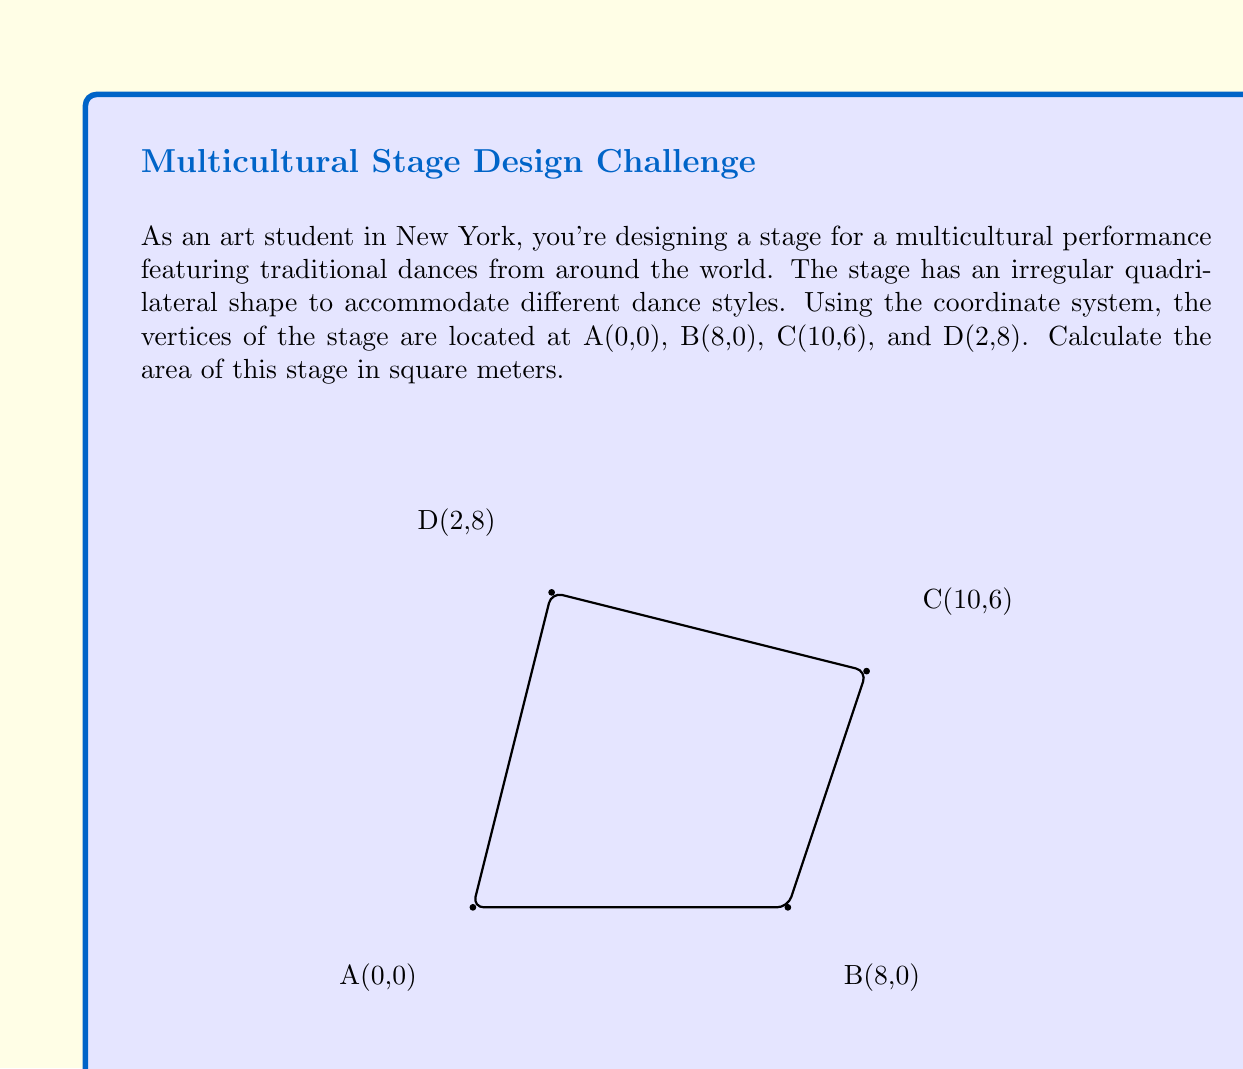Give your solution to this math problem. To calculate the area of this irregular quadrilateral stage, we can use the shoelace formula (also known as the surveyor's formula). This method works for any polygon given the coordinates of its vertices.

The shoelace formula for a quadrilateral ABCD is:

$$Area = \frac{1}{2}|(x_A y_B + x_B y_C + x_C y_D + x_D y_A) - (y_A x_B + y_B x_C + y_C x_D + y_D x_A)|$$

Where $(x_i, y_i)$ are the coordinates of vertex $i$.

Let's substitute the given coordinates:

A(0,0), B(8,0), C(10,6), D(2,8)

$$\begin{align*}
Area &= \frac{1}{2}|(0 \cdot 0 + 8 \cdot 6 + 10 \cdot 8 + 2 \cdot 0) - (0 \cdot 8 + 0 \cdot 10 + 6 \cdot 2 + 8 \cdot 0)|\\
&= \frac{1}{2}|(48 + 80) - (12)|\\
&= \frac{1}{2}|128 - 12|\\
&= \frac{1}{2}|116|\\
&= \frac{1}{2} \cdot 116\\
&= 58
\end{align*}$$

Therefore, the area of the stage is 58 square meters.
Answer: 58 m² 